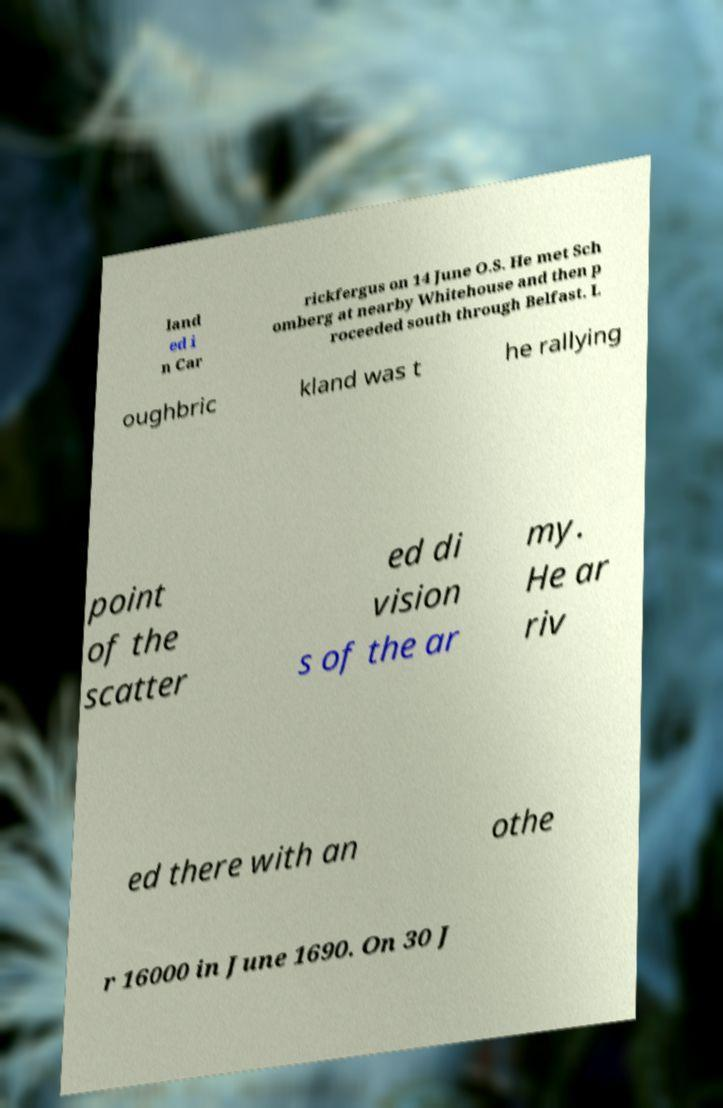What messages or text are displayed in this image? I need them in a readable, typed format. land ed i n Car rickfergus on 14 June O.S. He met Sch omberg at nearby Whitehouse and then p roceeded south through Belfast. L oughbric kland was t he rallying point of the scatter ed di vision s of the ar my. He ar riv ed there with an othe r 16000 in June 1690. On 30 J 